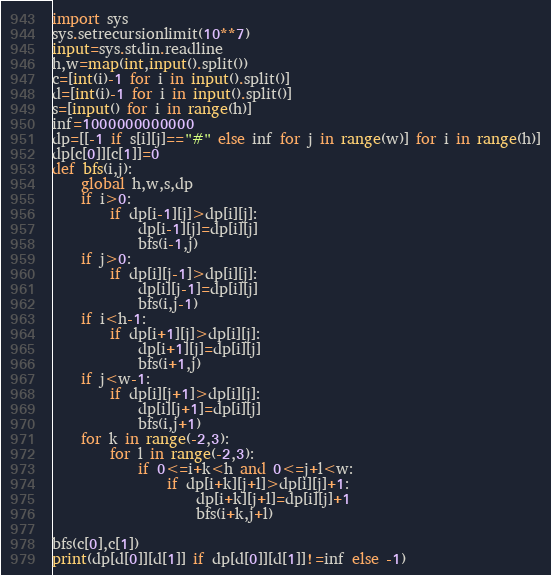<code> <loc_0><loc_0><loc_500><loc_500><_Python_>import sys
sys.setrecursionlimit(10**7)
input=sys.stdin.readline
h,w=map(int,input().split())
c=[int(i)-1 for i in input().split()]
d=[int(i)-1 for i in input().split()]
s=[input() for i in range(h)]
inf=1000000000000
dp=[[-1 if s[i][j]=="#" else inf for j in range(w)] for i in range(h)]
dp[c[0]][c[1]]=0
def bfs(i,j):
    global h,w,s,dp
    if i>0:
        if dp[i-1][j]>dp[i][j]:
            dp[i-1][j]=dp[i][j]
            bfs(i-1,j)
    if j>0:
        if dp[i][j-1]>dp[i][j]:
            dp[i][j-1]=dp[i][j]
            bfs(i,j-1)
    if i<h-1:
        if dp[i+1][j]>dp[i][j]:
            dp[i+1][j]=dp[i][j]
            bfs(i+1,j)
    if j<w-1:
        if dp[i][j+1]>dp[i][j]:
            dp[i][j+1]=dp[i][j]
            bfs(i,j+1)
    for k in range(-2,3):
        for l in range(-2,3):
            if 0<=i+k<h and 0<=j+l<w:
                if dp[i+k][j+l]>dp[i][j]+1:
                    dp[i+k][j+l]=dp[i][j]+1
                    bfs(i+k,j+l)

bfs(c[0],c[1])
print(dp[d[0]][d[1]] if dp[d[0]][d[1]]!=inf else -1)</code> 